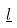Convert formula to latex. <formula><loc_0><loc_0><loc_500><loc_500>\underline { l }</formula> 